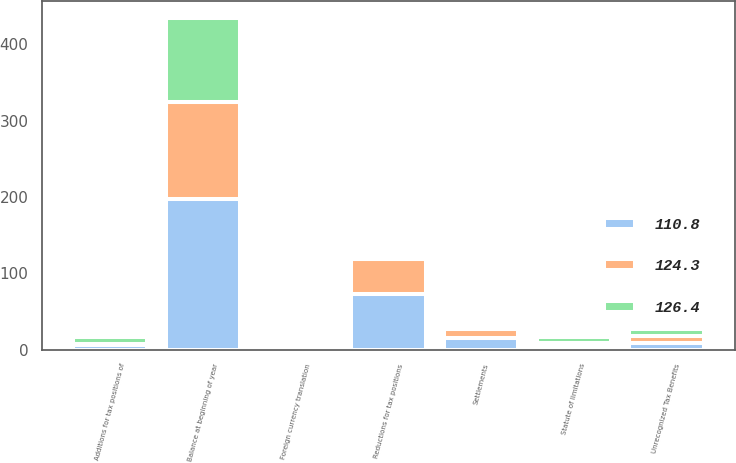<chart> <loc_0><loc_0><loc_500><loc_500><stacked_bar_chart><ecel><fcel>Unrecognized Tax Benefits<fcel>Balance at beginning of year<fcel>Additions for tax positions of<fcel>Reductions for tax positions<fcel>Settlements<fcel>Statute of limitations<fcel>Foreign currency translation<nl><fcel>126.4<fcel>9<fcel>110.8<fcel>9<fcel>0.5<fcel>1.4<fcel>8<fcel>1.7<nl><fcel>124.3<fcel>9<fcel>126.4<fcel>2.3<fcel>46.9<fcel>11<fcel>3.7<fcel>0.8<nl><fcel>110.8<fcel>9<fcel>197.8<fcel>5.7<fcel>72.4<fcel>15.6<fcel>4.8<fcel>0.6<nl></chart> 